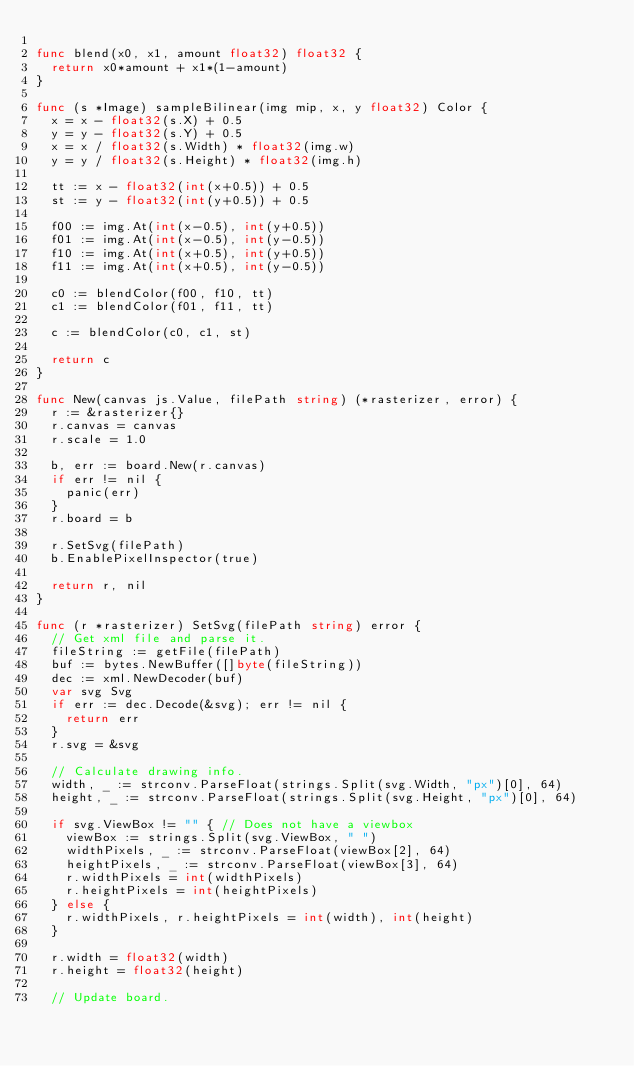<code> <loc_0><loc_0><loc_500><loc_500><_Go_>
func blend(x0, x1, amount float32) float32 {
	return x0*amount + x1*(1-amount)
}

func (s *Image) sampleBilinear(img mip, x, y float32) Color {
	x = x - float32(s.X) + 0.5
	y = y - float32(s.Y) + 0.5
	x = x / float32(s.Width) * float32(img.w)
	y = y / float32(s.Height) * float32(img.h)

	tt := x - float32(int(x+0.5)) + 0.5
	st := y - float32(int(y+0.5)) + 0.5

	f00 := img.At(int(x-0.5), int(y+0.5))
	f01 := img.At(int(x-0.5), int(y-0.5))
	f10 := img.At(int(x+0.5), int(y+0.5))
	f11 := img.At(int(x+0.5), int(y-0.5))

	c0 := blendColor(f00, f10, tt)
	c1 := blendColor(f01, f11, tt)

	c := blendColor(c0, c1, st)

	return c
}

func New(canvas js.Value, filePath string) (*rasterizer, error) {
	r := &rasterizer{}
	r.canvas = canvas
	r.scale = 1.0

	b, err := board.New(r.canvas)
	if err != nil {
		panic(err)
	}
	r.board = b

	r.SetSvg(filePath)
	b.EnablePixelInspector(true)

	return r, nil
}

func (r *rasterizer) SetSvg(filePath string) error {
	// Get xml file and parse it.
	fileString := getFile(filePath)
	buf := bytes.NewBuffer([]byte(fileString))
	dec := xml.NewDecoder(buf)
	var svg Svg
	if err := dec.Decode(&svg); err != nil {
		return err
	}
	r.svg = &svg

	// Calculate drawing info.
	width, _ := strconv.ParseFloat(strings.Split(svg.Width, "px")[0], 64)
	height, _ := strconv.ParseFloat(strings.Split(svg.Height, "px")[0], 64)

	if svg.ViewBox != "" { // Does not have a viewbox
		viewBox := strings.Split(svg.ViewBox, " ")
		widthPixels, _ := strconv.ParseFloat(viewBox[2], 64)
		heightPixels, _ := strconv.ParseFloat(viewBox[3], 64)
		r.widthPixels = int(widthPixels)
		r.heightPixels = int(heightPixels)
	} else {
		r.widthPixels, r.heightPixels = int(width), int(height)
	}

	r.width = float32(width)
	r.height = float32(height)

	// Update board.</code> 